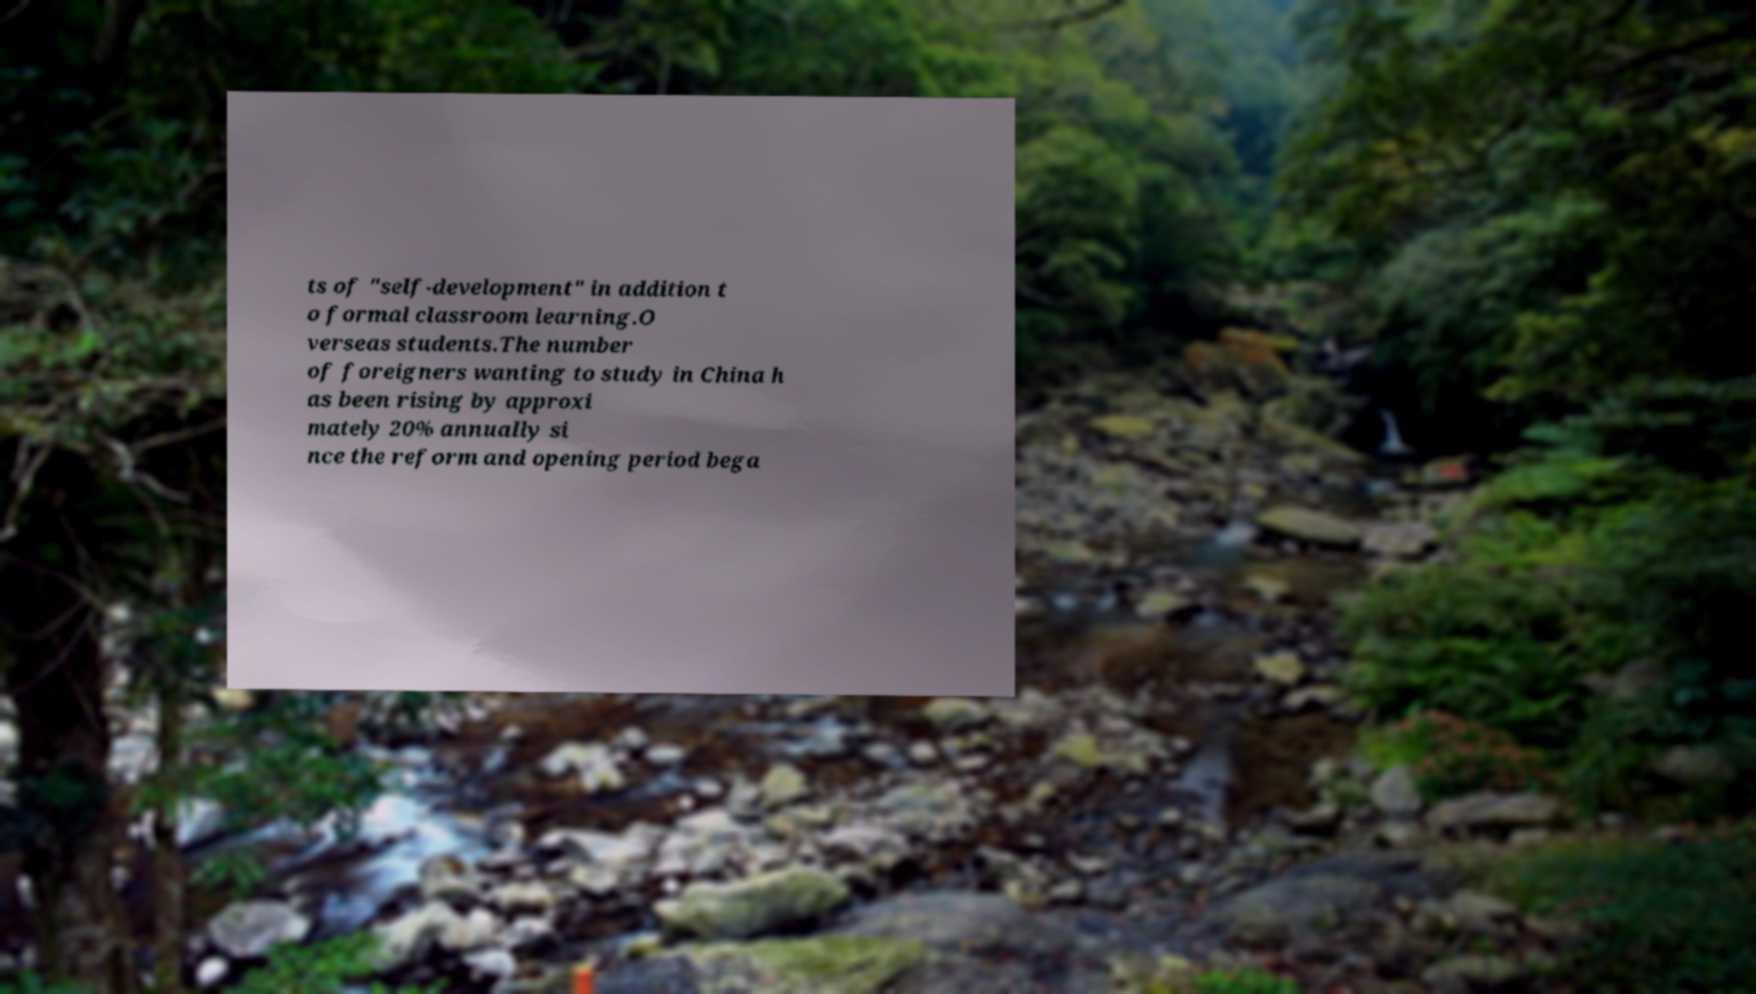Could you assist in decoding the text presented in this image and type it out clearly? ts of "self-development" in addition t o formal classroom learning.O verseas students.The number of foreigners wanting to study in China h as been rising by approxi mately 20% annually si nce the reform and opening period bega 